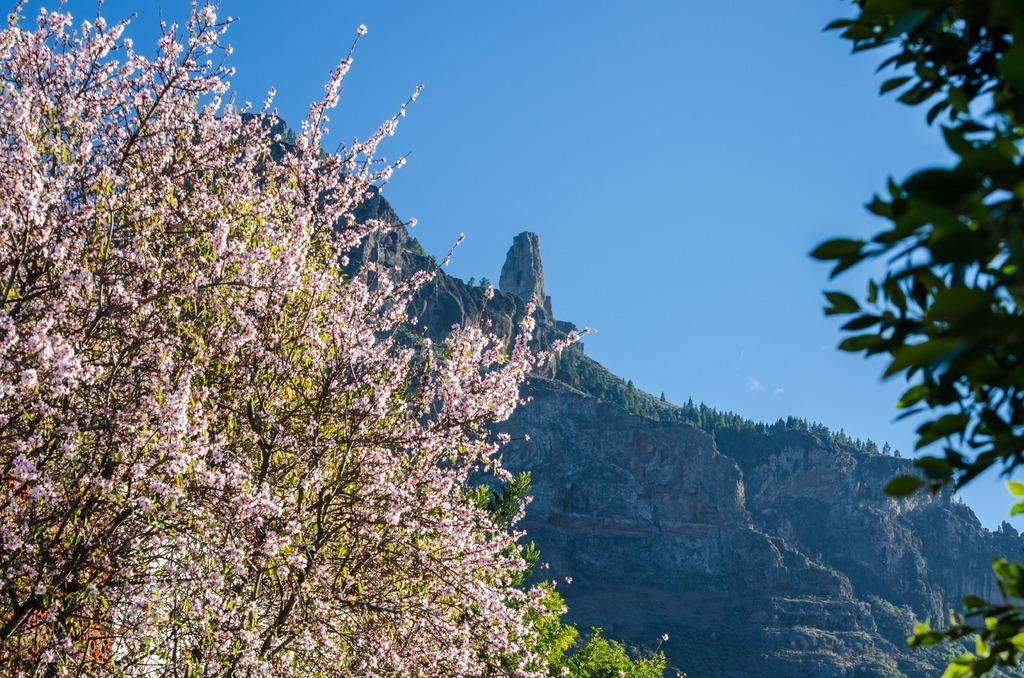Please provide a concise description of this image. In this picture we can see a few trees on the left and right side. Some greenery is visible in the background. Sky is blue in color. 